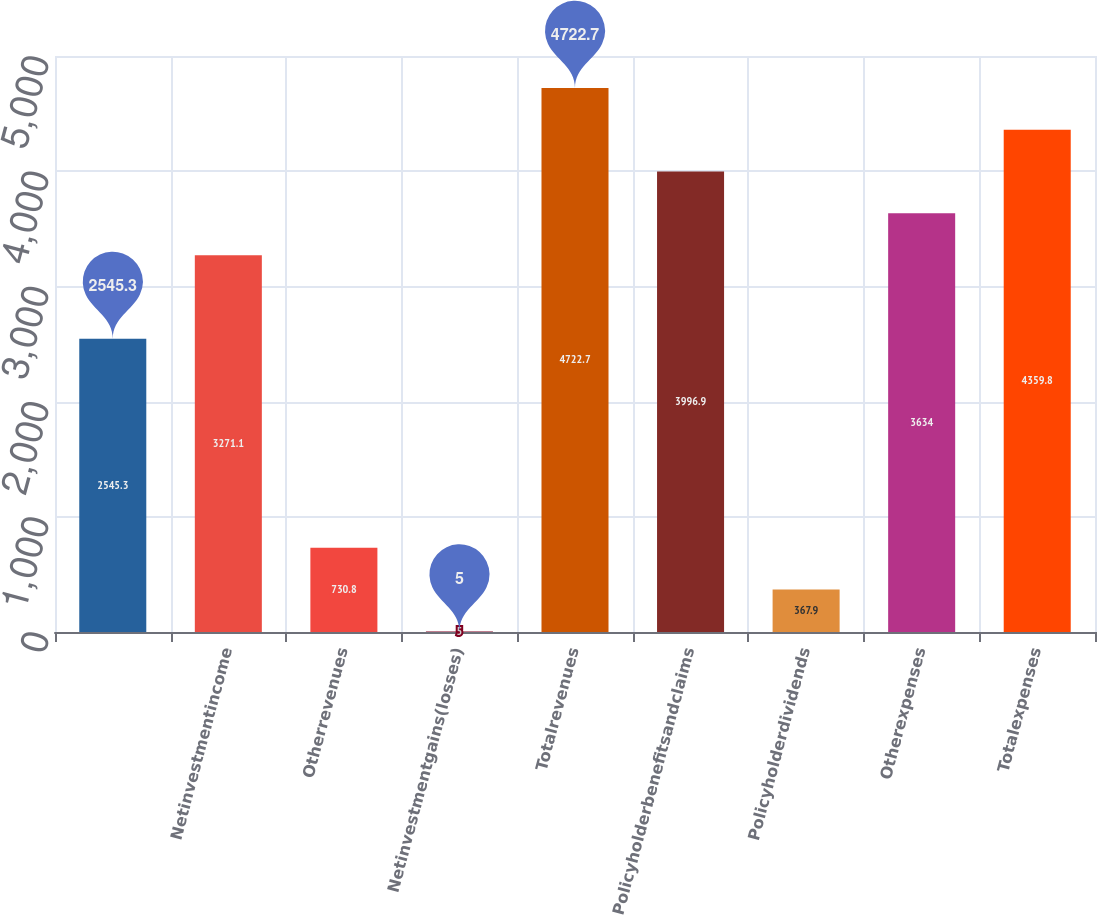<chart> <loc_0><loc_0><loc_500><loc_500><bar_chart><ecel><fcel>Netinvestmentincome<fcel>Otherrevenues<fcel>Netinvestmentgains(losses)<fcel>Totalrevenues<fcel>Policyholderbenefitsandclaims<fcel>Policyholderdividends<fcel>Otherexpenses<fcel>Totalexpenses<nl><fcel>2545.3<fcel>3271.1<fcel>730.8<fcel>5<fcel>4722.7<fcel>3996.9<fcel>367.9<fcel>3634<fcel>4359.8<nl></chart> 